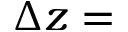<formula> <loc_0><loc_0><loc_500><loc_500>\Delta z =</formula> 